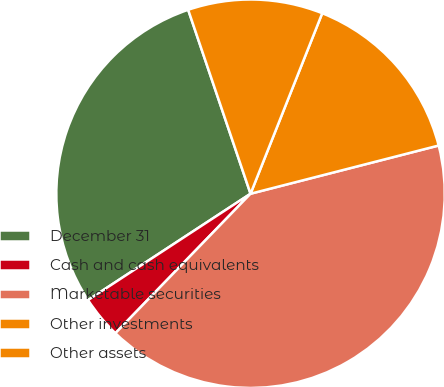Convert chart to OTSL. <chart><loc_0><loc_0><loc_500><loc_500><pie_chart><fcel>December 31<fcel>Cash and cash equivalents<fcel>Marketable securities<fcel>Other investments<fcel>Other assets<nl><fcel>29.02%<fcel>3.53%<fcel>41.24%<fcel>14.99%<fcel>11.22%<nl></chart> 